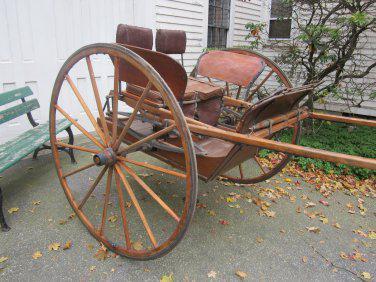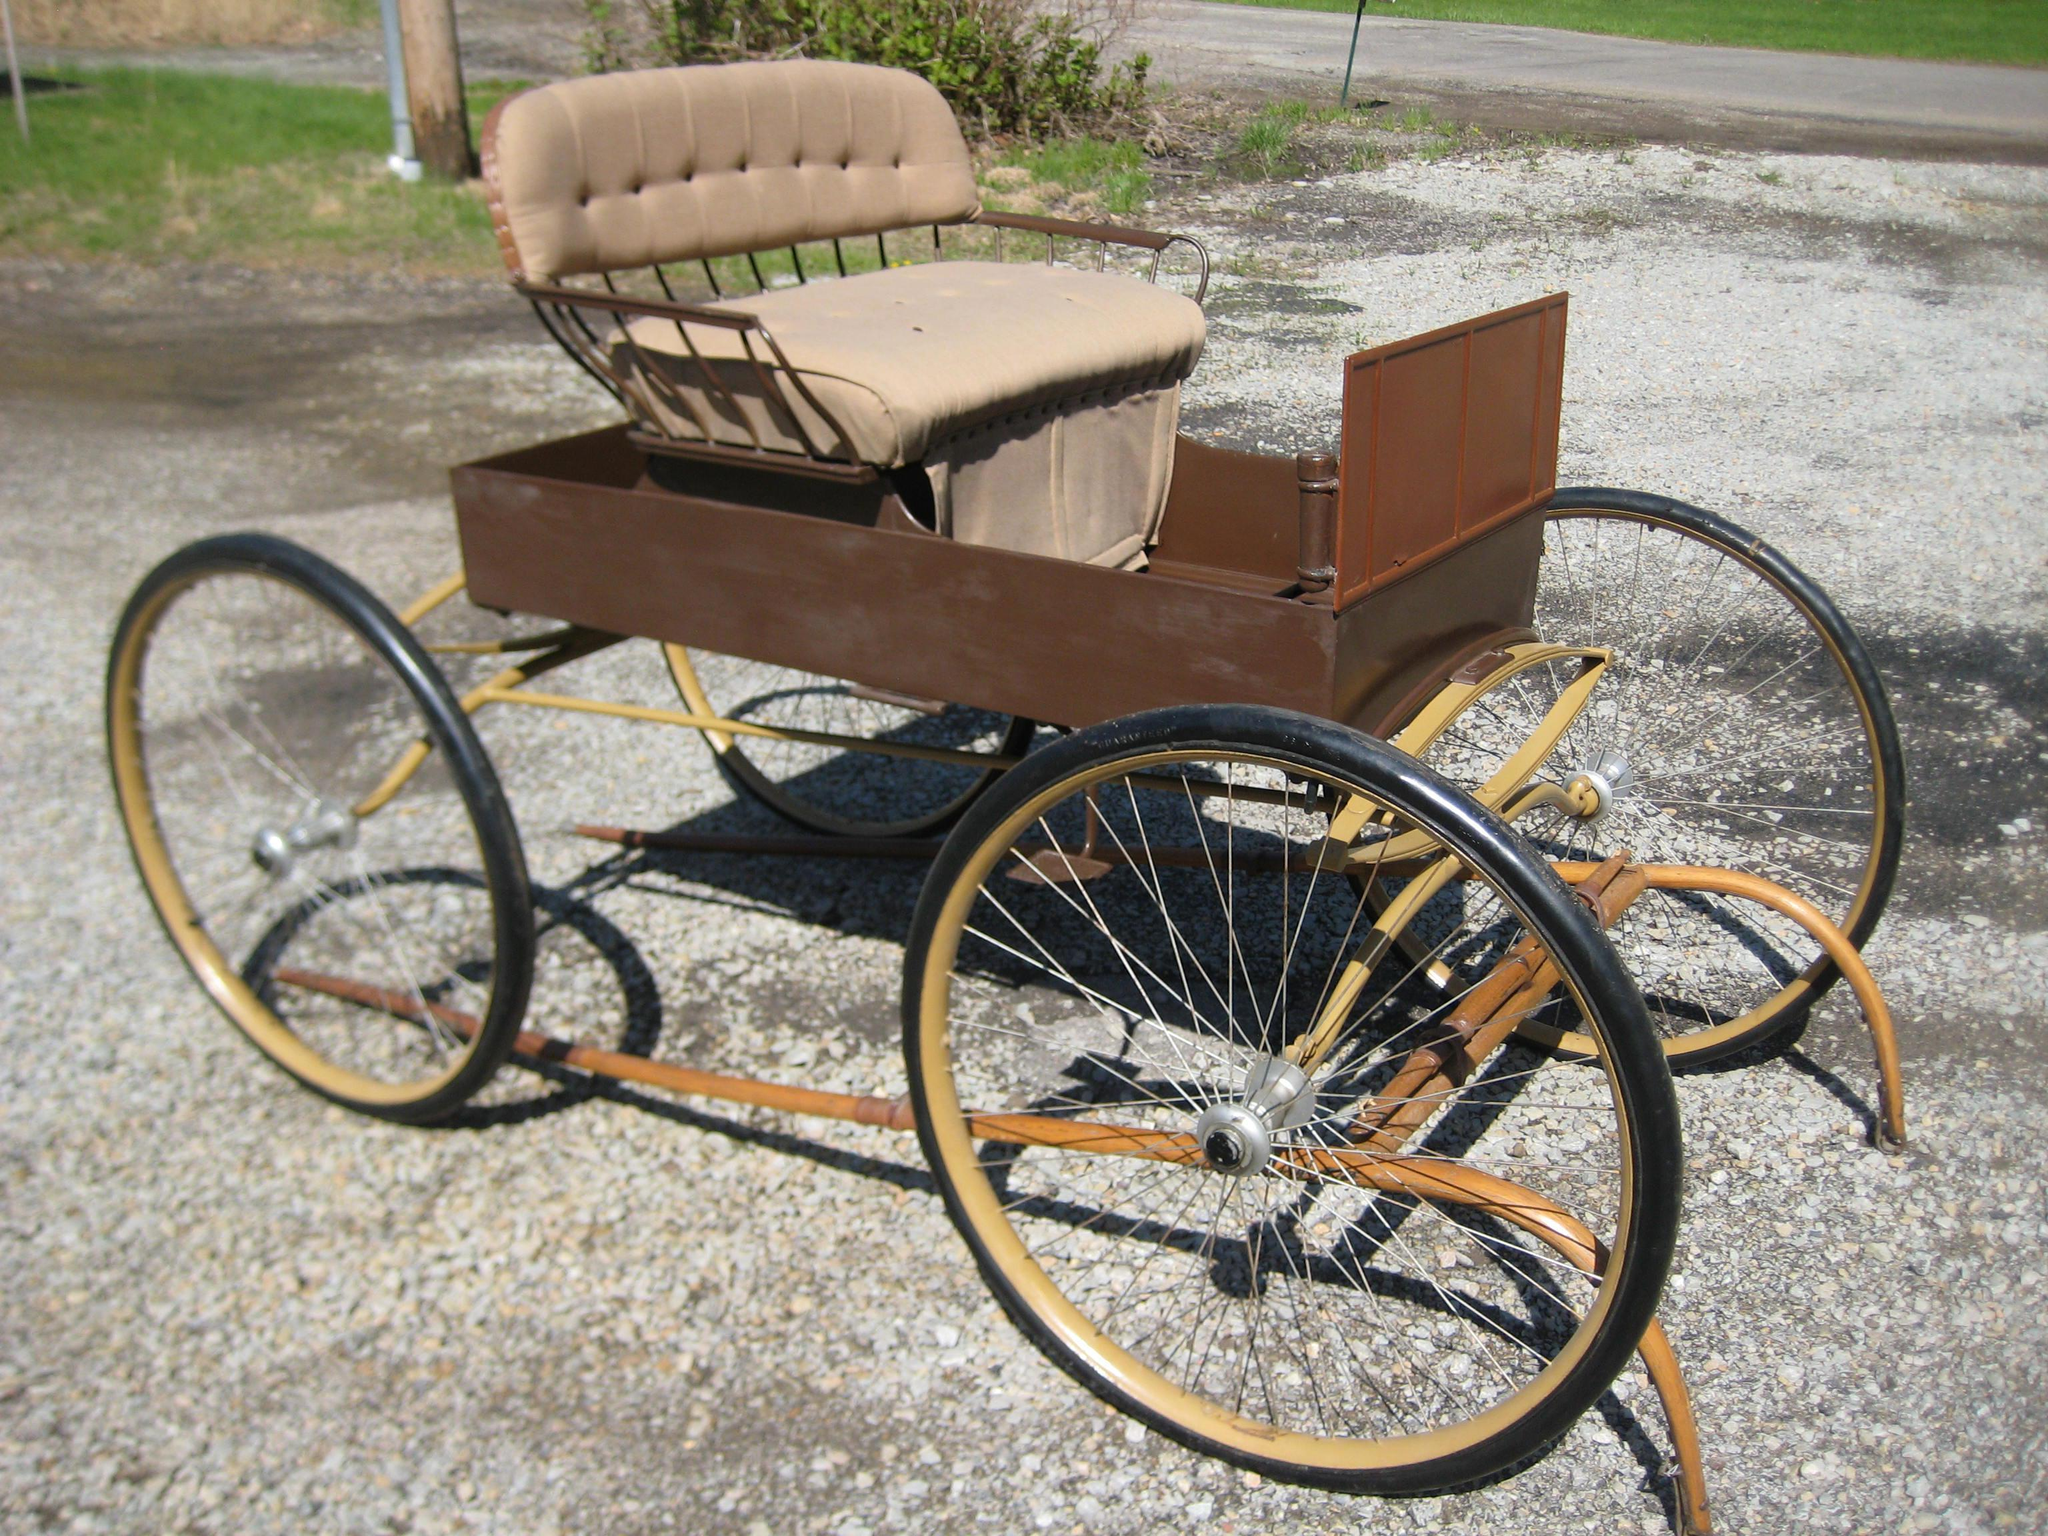The first image is the image on the left, the second image is the image on the right. For the images displayed, is the sentence "Left image features a four-wheeled black cart." factually correct? Answer yes or no. No. 